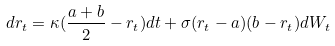Convert formula to latex. <formula><loc_0><loc_0><loc_500><loc_500>d r _ { t } = \kappa ( \frac { a + b } { 2 } - r _ { t } ) d t + \sigma ( r _ { t } - a ) ( b - r _ { t } ) d W _ { t }</formula> 